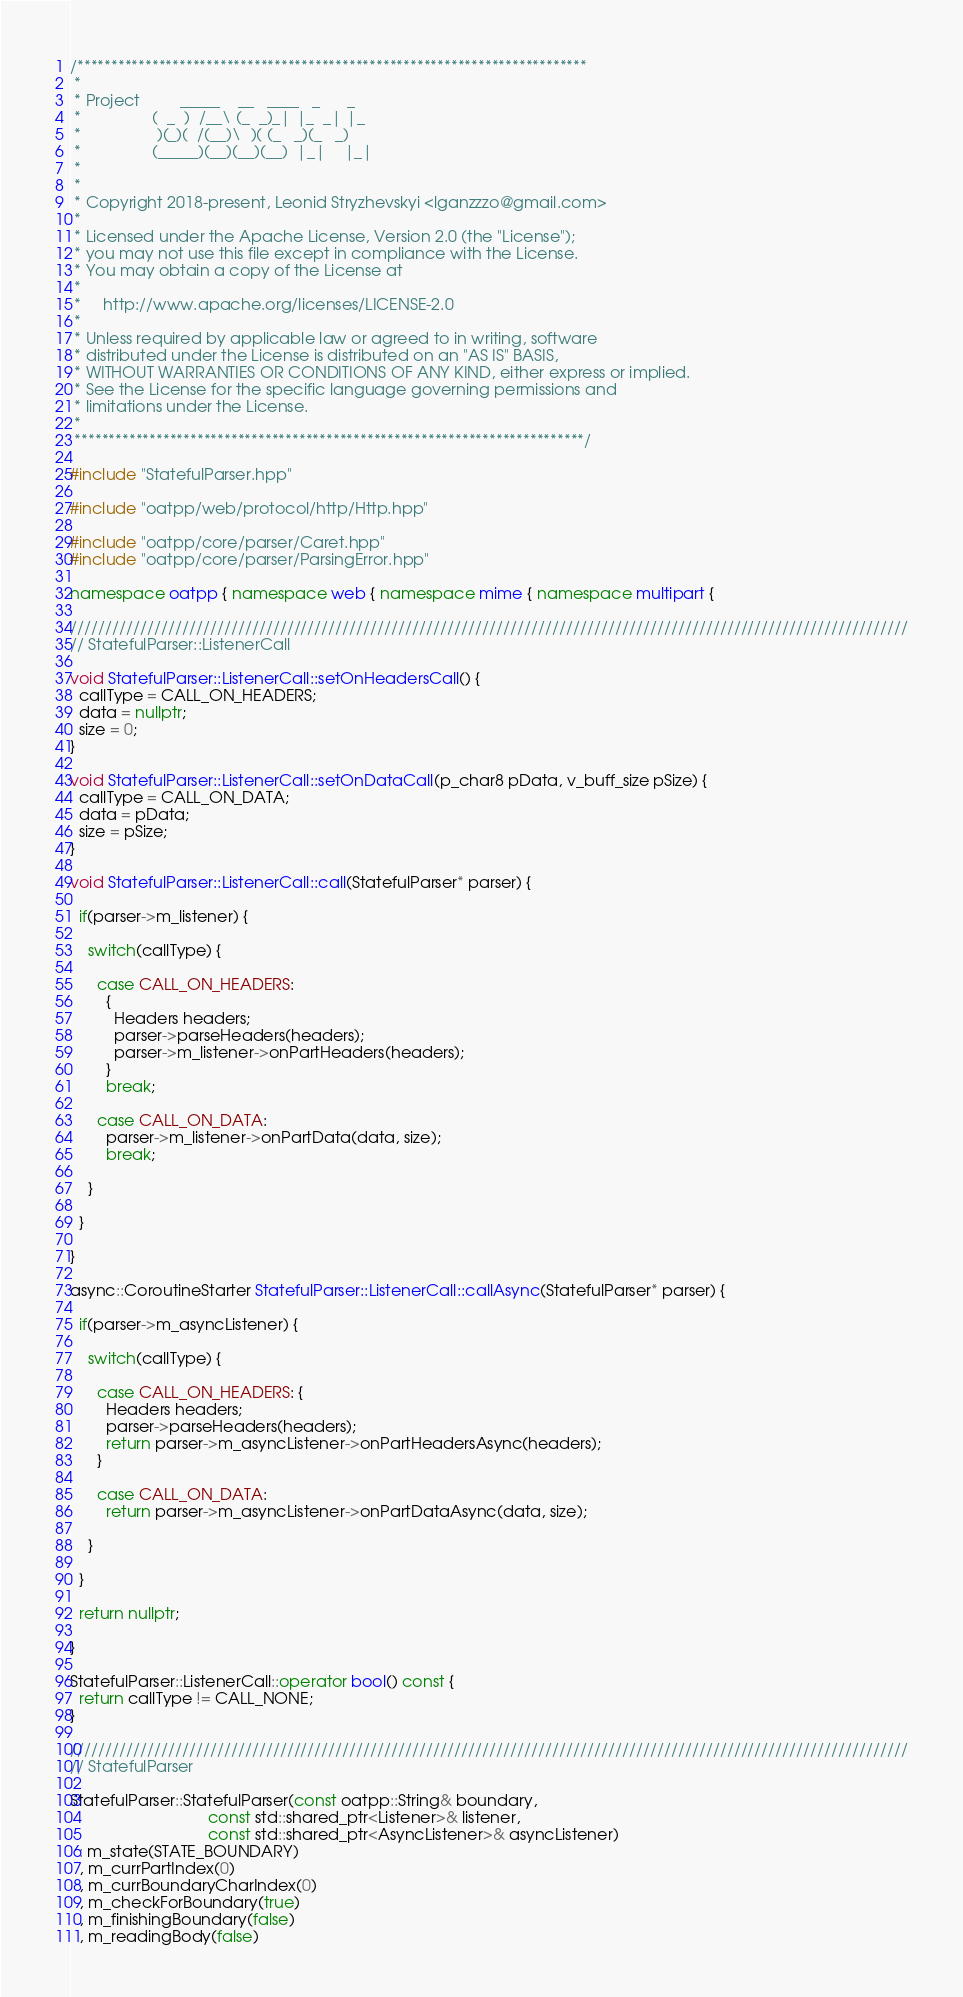<code> <loc_0><loc_0><loc_500><loc_500><_C++_>/***************************************************************************
 *
 * Project         _____    __   ____   _      _
 *                (  _  )  /__\ (_  _)_| |_  _| |_
 *                 )(_)(  /(__)\  )( (_   _)(_   _)
 *                (_____)(__)(__)(__)  |_|    |_|
 *
 *
 * Copyright 2018-present, Leonid Stryzhevskyi <lganzzzo@gmail.com>
 *
 * Licensed under the Apache License, Version 2.0 (the "License");
 * you may not use this file except in compliance with the License.
 * You may obtain a copy of the License at
 *
 *     http://www.apache.org/licenses/LICENSE-2.0
 *
 * Unless required by applicable law or agreed to in writing, software
 * distributed under the License is distributed on an "AS IS" BASIS,
 * WITHOUT WARRANTIES OR CONDITIONS OF ANY KIND, either express or implied.
 * See the License for the specific language governing permissions and
 * limitations under the License.
 *
 ***************************************************************************/

#include "StatefulParser.hpp"

#include "oatpp/web/protocol/http/Http.hpp"

#include "oatpp/core/parser/Caret.hpp"
#include "oatpp/core/parser/ParsingError.hpp"

namespace oatpp { namespace web { namespace mime { namespace multipart {

////////////////////////////////////////////////////////////////////////////////////////////////////////////////////////
// StatefulParser::ListenerCall

void StatefulParser::ListenerCall::setOnHeadersCall() {
  callType = CALL_ON_HEADERS;
  data = nullptr;
  size = 0;
}

void StatefulParser::ListenerCall::setOnDataCall(p_char8 pData, v_buff_size pSize) {
  callType = CALL_ON_DATA;
  data = pData;
  size = pSize;
}

void StatefulParser::ListenerCall::call(StatefulParser* parser) {

  if(parser->m_listener) {

    switch(callType) {

      case CALL_ON_HEADERS:
        {
          Headers headers;
          parser->parseHeaders(headers);
          parser->m_listener->onPartHeaders(headers);
        }
        break;

      case CALL_ON_DATA:
        parser->m_listener->onPartData(data, size);
        break;

    }

  }

}

async::CoroutineStarter StatefulParser::ListenerCall::callAsync(StatefulParser* parser) {

  if(parser->m_asyncListener) {

    switch(callType) {

      case CALL_ON_HEADERS: {
        Headers headers;
        parser->parseHeaders(headers);
        return parser->m_asyncListener->onPartHeadersAsync(headers);
      }

      case CALL_ON_DATA:
        return parser->m_asyncListener->onPartDataAsync(data, size);

    }

  }

  return nullptr;

}

StatefulParser::ListenerCall::operator bool() const {
  return callType != CALL_NONE;
}

////////////////////////////////////////////////////////////////////////////////////////////////////////////////////////
// StatefulParser

StatefulParser::StatefulParser(const oatpp::String& boundary,
                               const std::shared_ptr<Listener>& listener,
                               const std::shared_ptr<AsyncListener>& asyncListener)
  : m_state(STATE_BOUNDARY)
  , m_currPartIndex(0)
  , m_currBoundaryCharIndex(0)
  , m_checkForBoundary(true)
  , m_finishingBoundary(false)
  , m_readingBody(false)</code> 